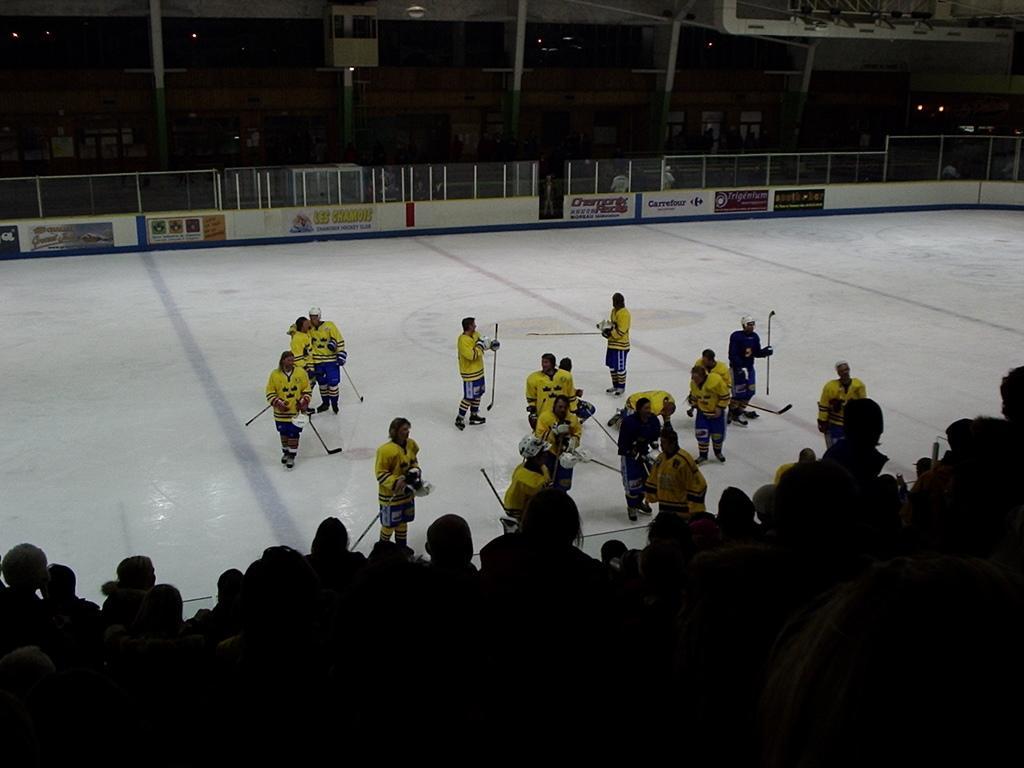How would you summarize this image in a sentence or two? In this image I can see the group of people are standing on the ice and these people are holding the sticks. In-front of these people I can see many people. In the background I can see the railing, many boards and the lights. 